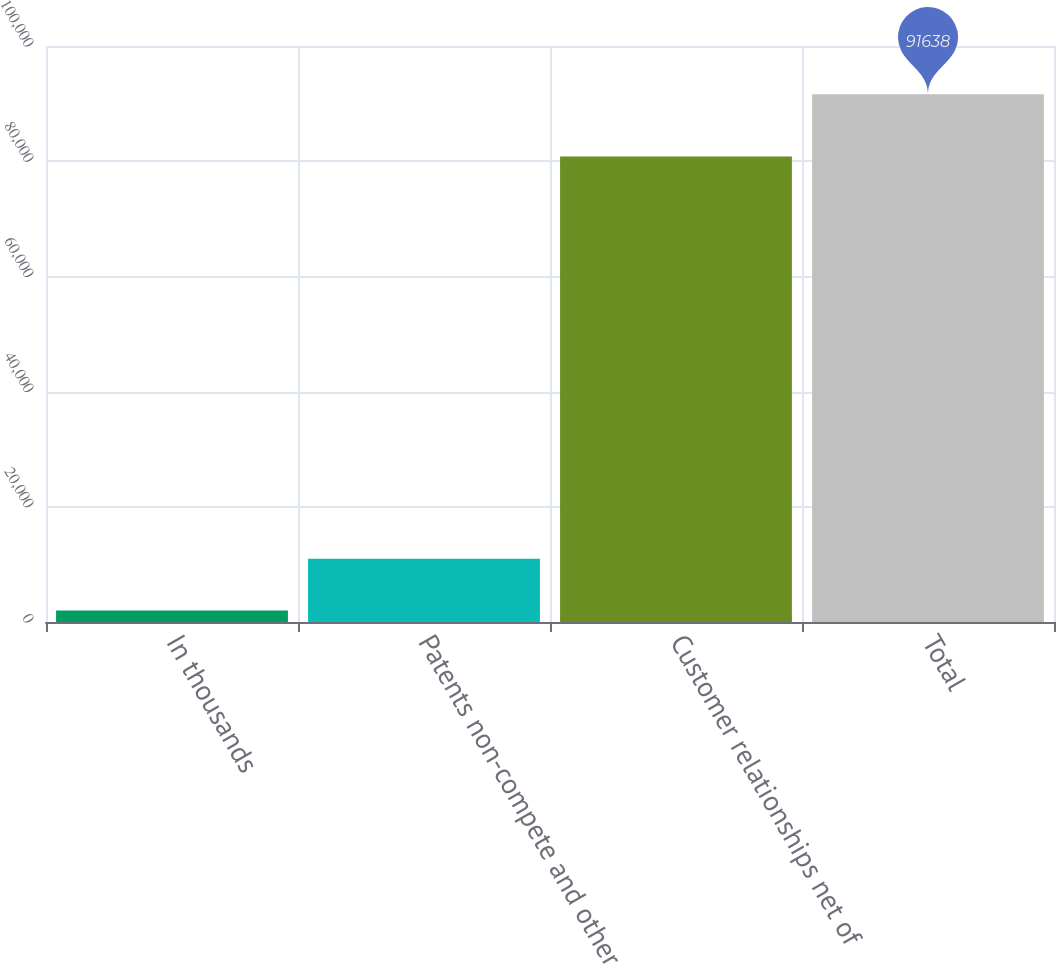Convert chart to OTSL. <chart><loc_0><loc_0><loc_500><loc_500><bar_chart><fcel>In thousands<fcel>Patents non-compete and other<fcel>Customer relationships net of<fcel>Total<nl><fcel>2009<fcel>10971.9<fcel>80806<fcel>91638<nl></chart> 